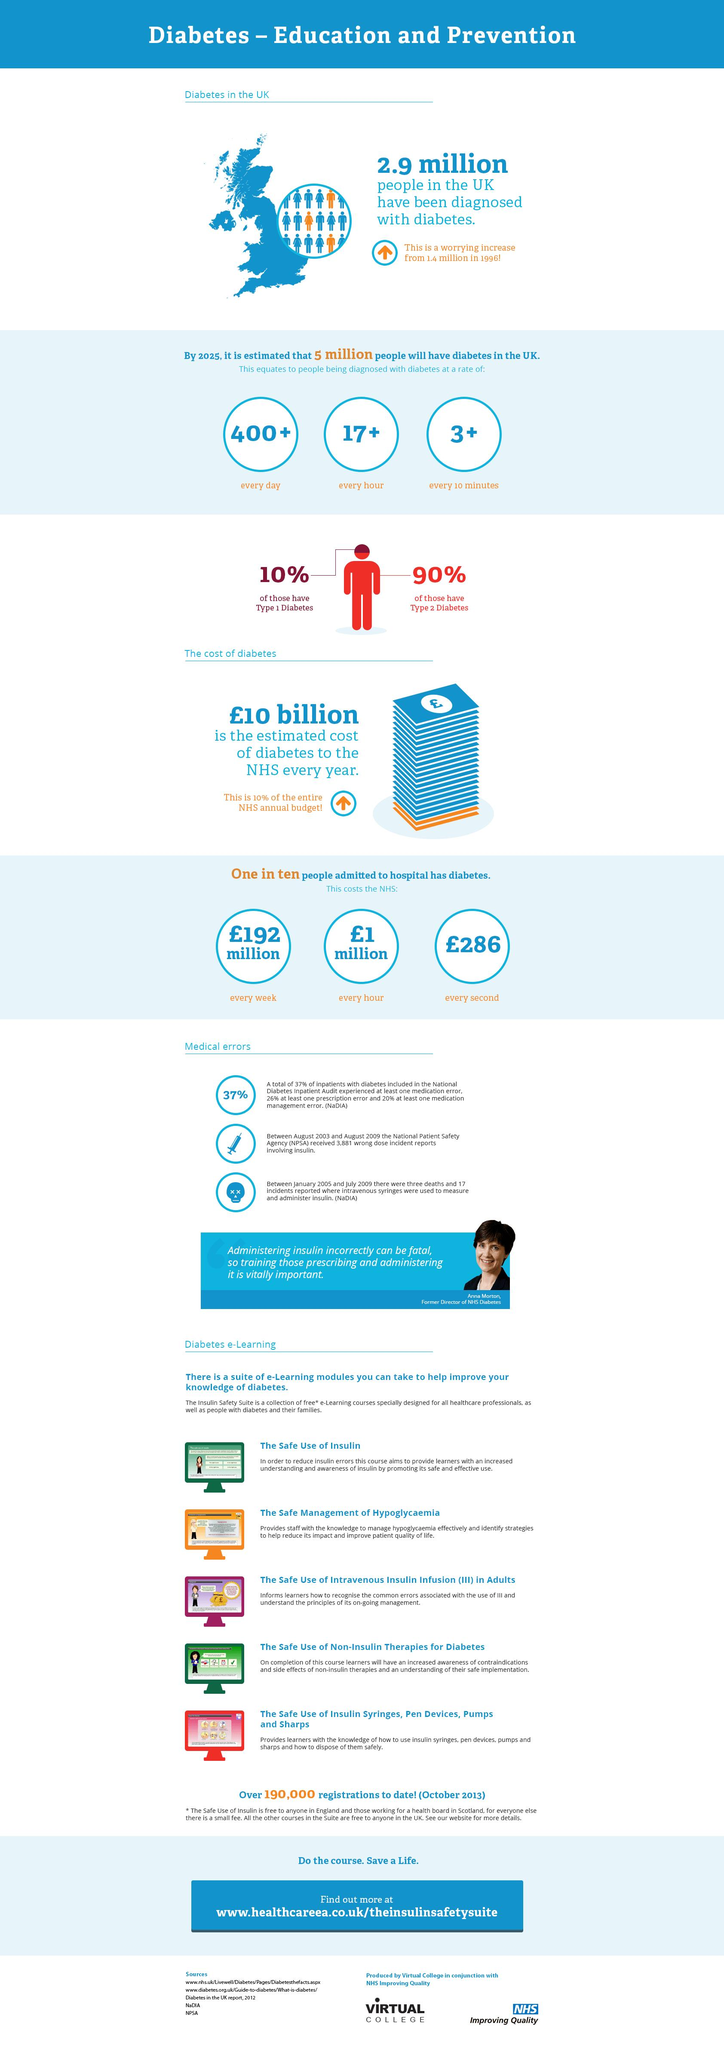Highlight a few significant elements in this photo. It is estimated that every day, over 400 civilians in the UK will be affected by diabetes. According to statistics, an estimated 17 people will be diagnosed with diabetes every hour. According to statistics, approximately 3 new cases of diabetes are diagnosed every 10 minutes. Out of the 10 people admitted to hospitals in the UK, it was found that 9 of them are not diabetic. According to statistics, it is estimated that approximately 90% of people in the United Kingdom have been diagnosed with Type 2 Diabetes. 